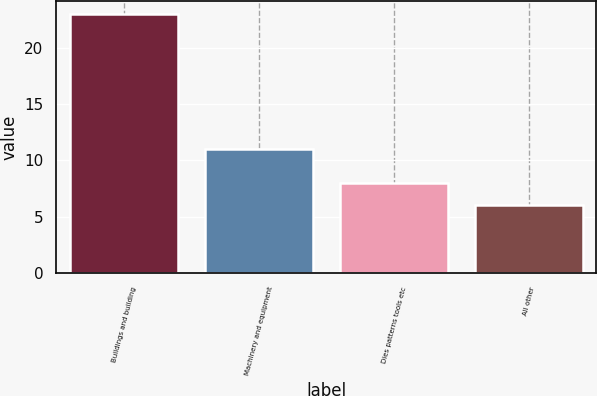<chart> <loc_0><loc_0><loc_500><loc_500><bar_chart><fcel>Buildings and building<fcel>Machinery and equipment<fcel>Dies patterns tools etc<fcel>All other<nl><fcel>23<fcel>11<fcel>8<fcel>6<nl></chart> 